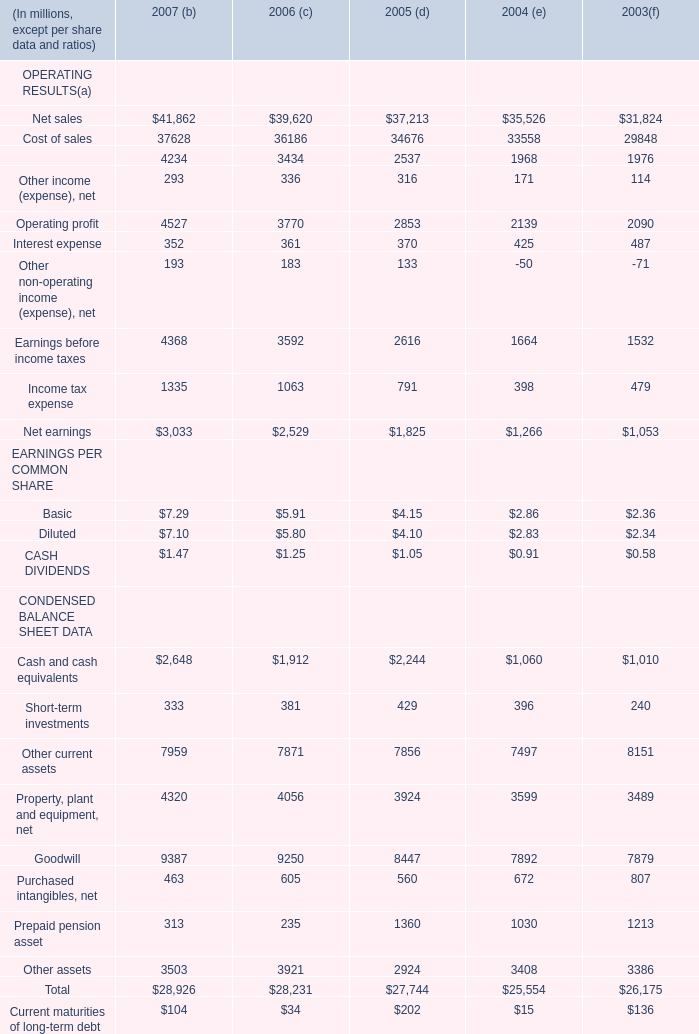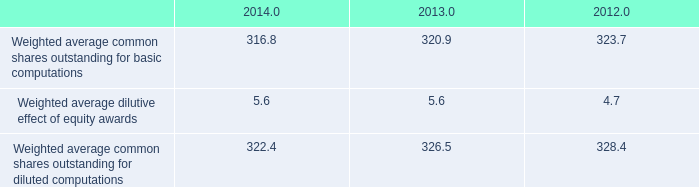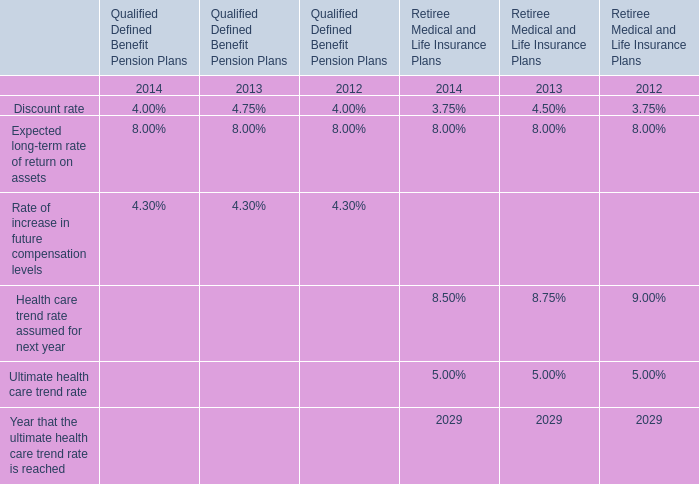what is the highest total amount of Long-term debt, net? 
Answer: 6072. 